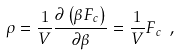<formula> <loc_0><loc_0><loc_500><loc_500>\rho = \frac { 1 } { V } \frac { \partial \left ( \beta F _ { c } \right ) } { \partial \beta } = \frac { 1 } { V } F _ { c } \ ,</formula> 